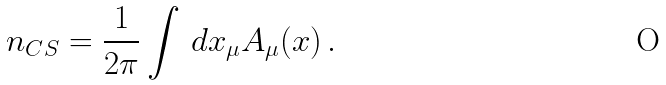Convert formula to latex. <formula><loc_0><loc_0><loc_500><loc_500>n _ { C S } = \frac { 1 } { 2 \pi } \int \, d x _ { \mu } A _ { \mu } ( x ) \, .</formula> 